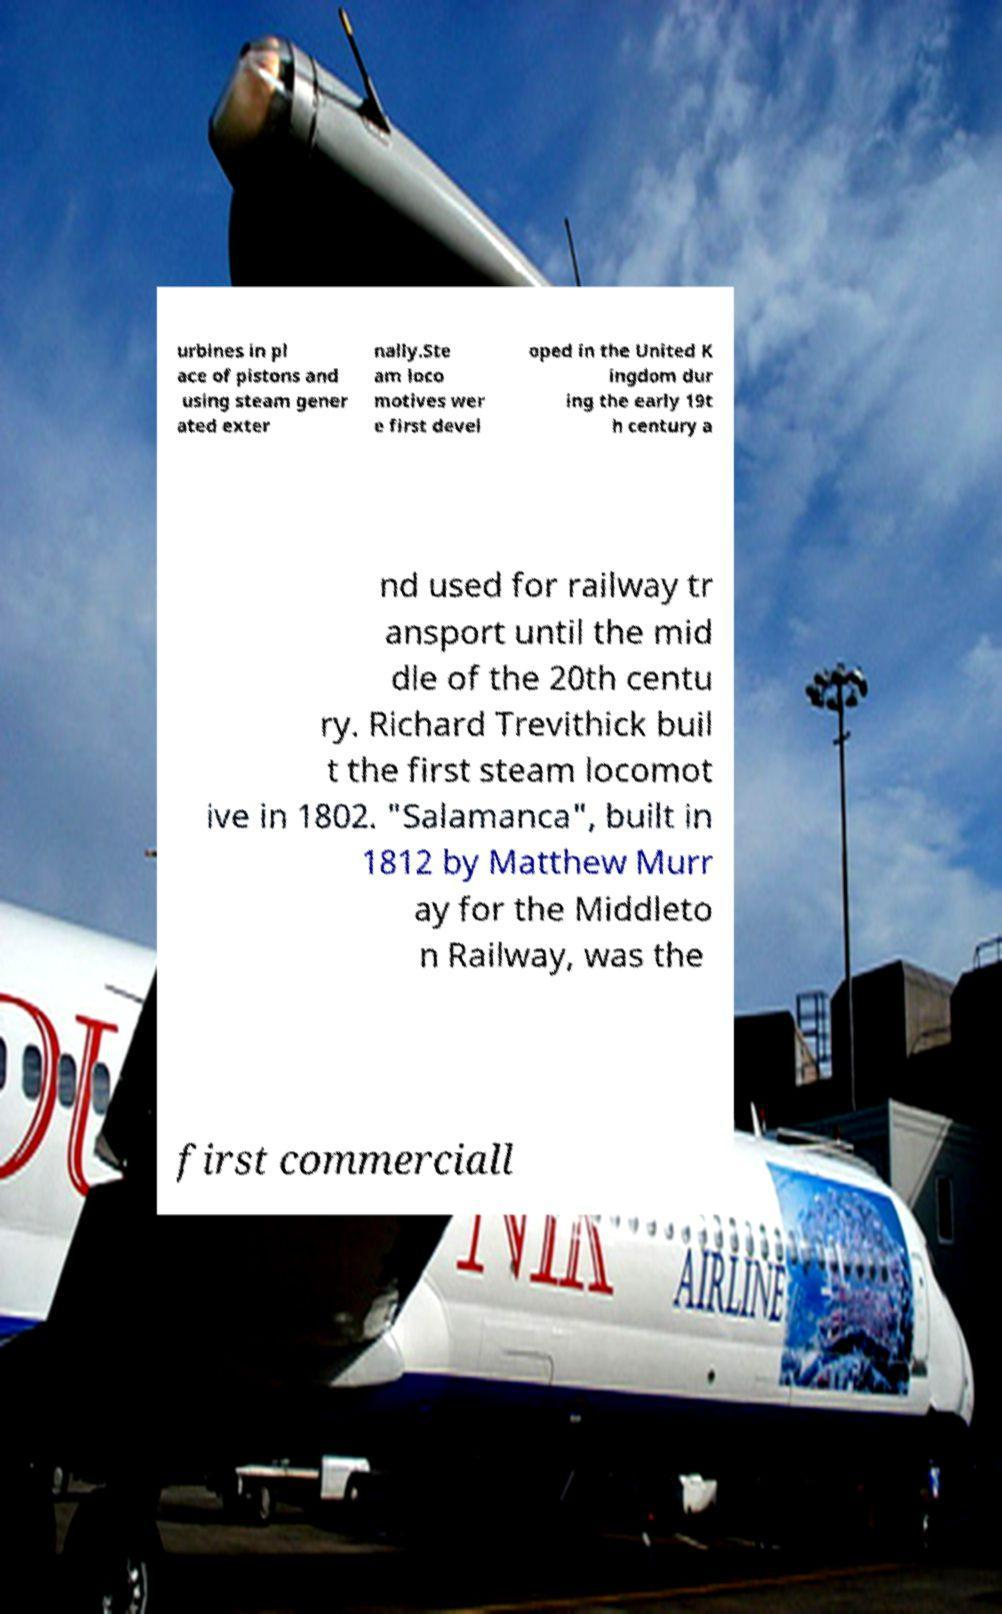Can you read and provide the text displayed in the image?This photo seems to have some interesting text. Can you extract and type it out for me? urbines in pl ace of pistons and using steam gener ated exter nally.Ste am loco motives wer e first devel oped in the United K ingdom dur ing the early 19t h century a nd used for railway tr ansport until the mid dle of the 20th centu ry. Richard Trevithick buil t the first steam locomot ive in 1802. "Salamanca", built in 1812 by Matthew Murr ay for the Middleto n Railway, was the first commerciall 